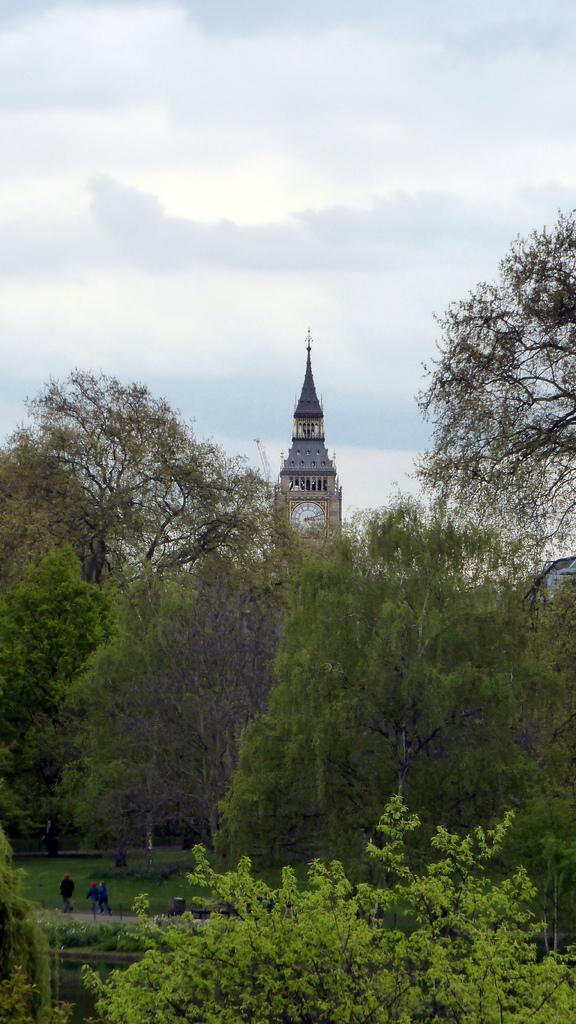In one or two sentences, can you explain what this image depicts? In the center of the image there is a tower. There are trees. At the top of the image there is sky. 